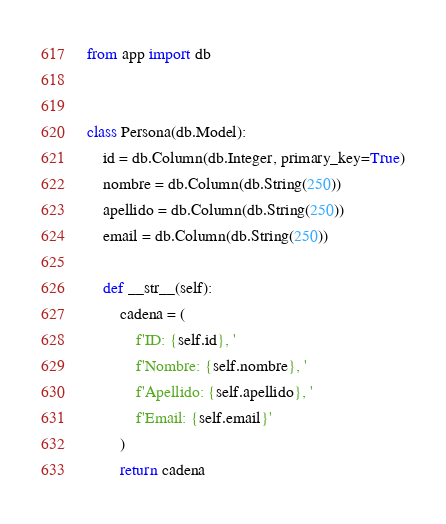<code> <loc_0><loc_0><loc_500><loc_500><_Python_>from app import db


class Persona(db.Model):
    id = db.Column(db.Integer, primary_key=True)
    nombre = db.Column(db.String(250))
    apellido = db.Column(db.String(250))
    email = db.Column(db.String(250))

    def __str__(self):
        cadena = (
            f'ID: {self.id}, '
            f'Nombre: {self.nombre}, '
            f'Apellido: {self.apellido}, '
            f'Email: {self.email}'
        )
        return cadena</code> 